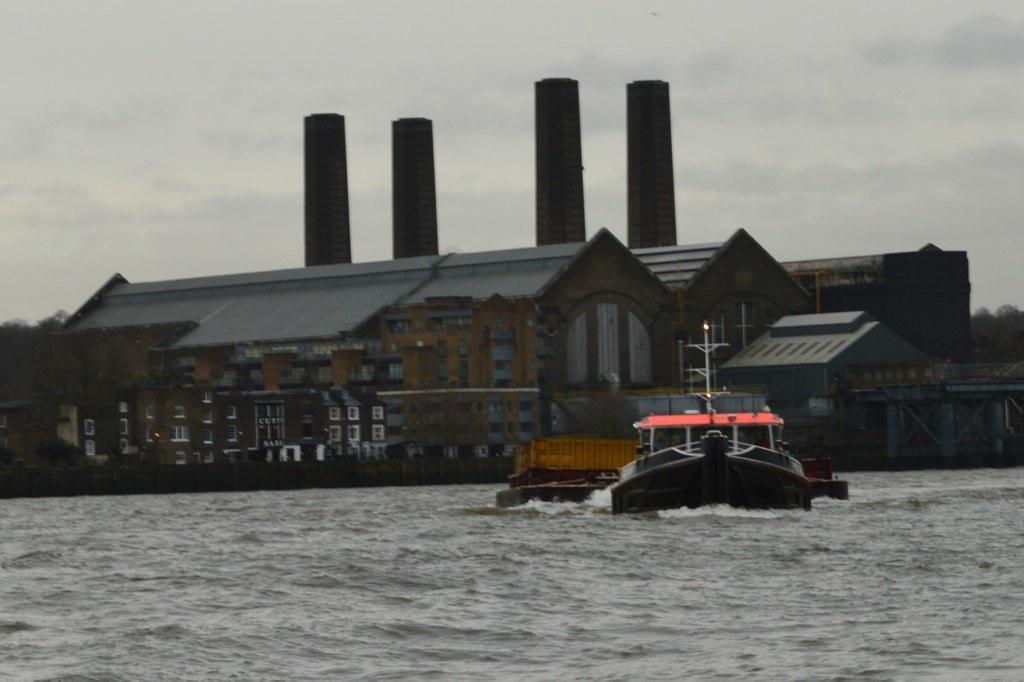Could you give a brief overview of what you see in this image? There is a boat on the water. In the back there are buildings with windows. In the background there is sky. 